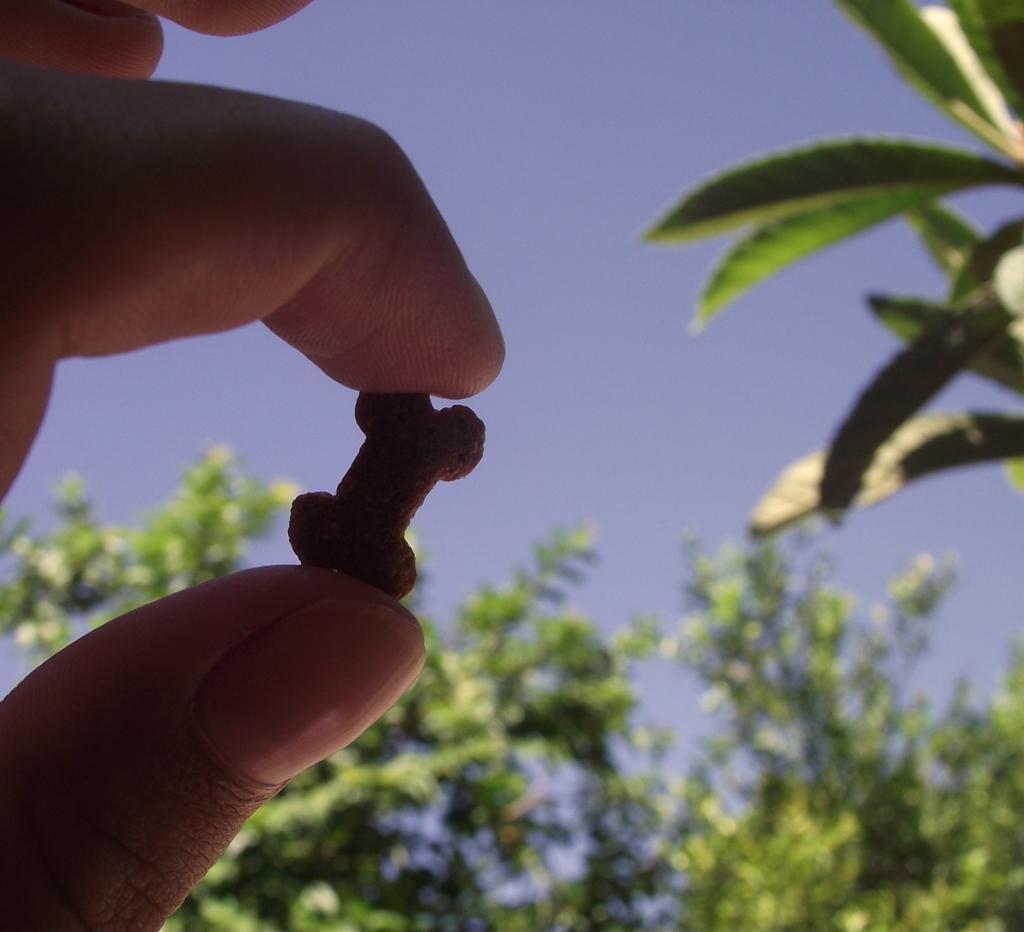In one or two sentences, can you explain what this image depicts? On the left corner of the image there are fingers of a person holding an object. In the background there are leaves. 